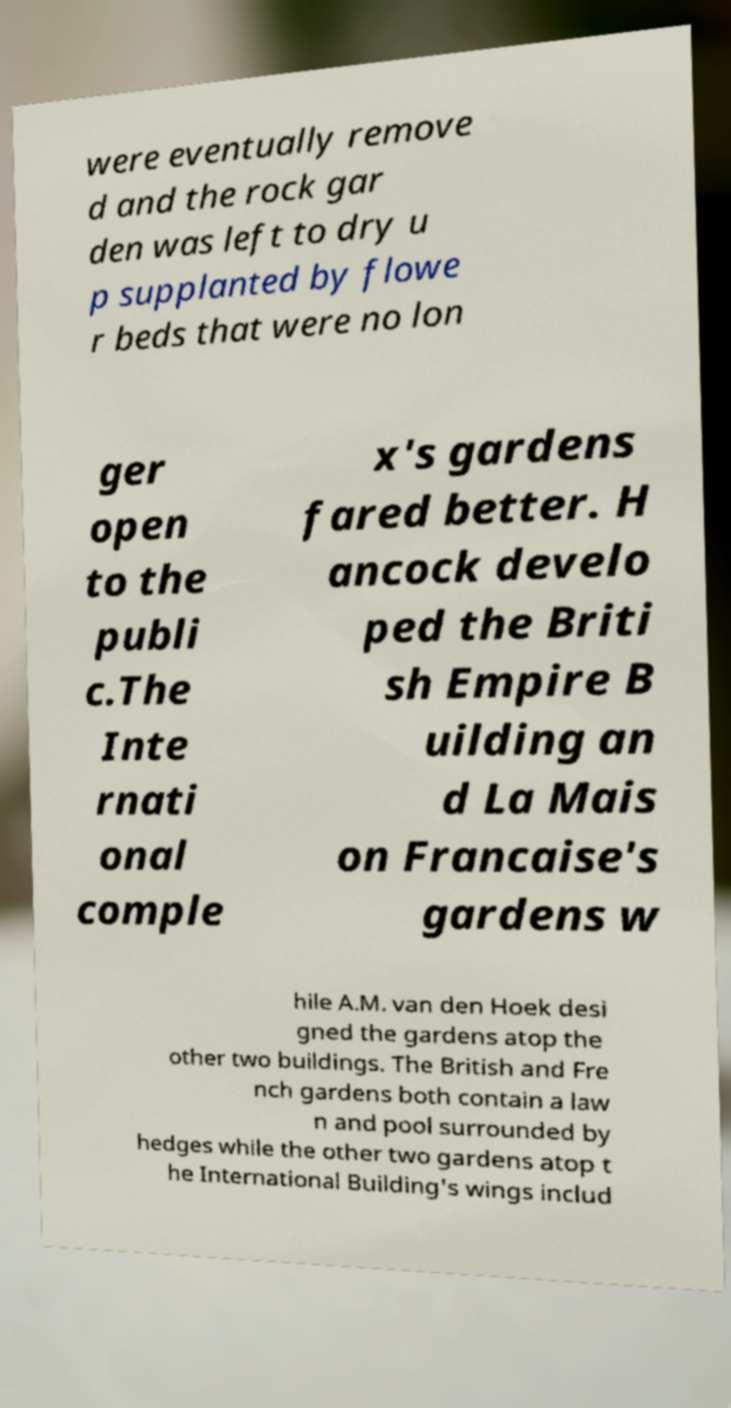Can you read and provide the text displayed in the image?This photo seems to have some interesting text. Can you extract and type it out for me? were eventually remove d and the rock gar den was left to dry u p supplanted by flowe r beds that were no lon ger open to the publi c.The Inte rnati onal comple x's gardens fared better. H ancock develo ped the Briti sh Empire B uilding an d La Mais on Francaise's gardens w hile A.M. van den Hoek desi gned the gardens atop the other two buildings. The British and Fre nch gardens both contain a law n and pool surrounded by hedges while the other two gardens atop t he International Building's wings includ 